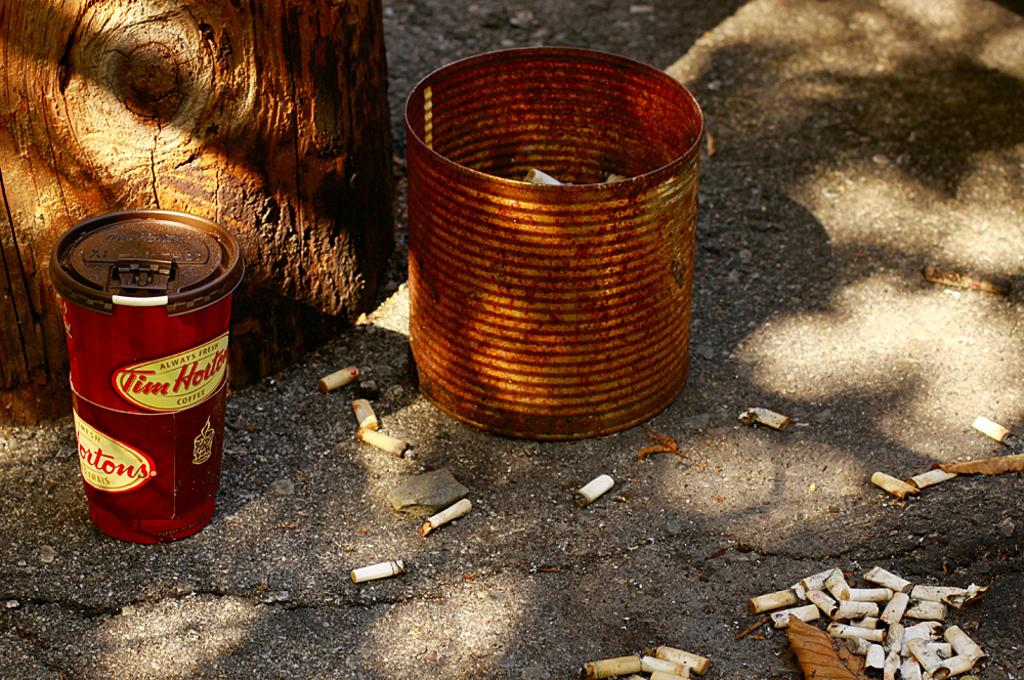<image>
Write a terse but informative summary of the picture. Rusted can next to a TIm Hortons cup and cigarette butts 